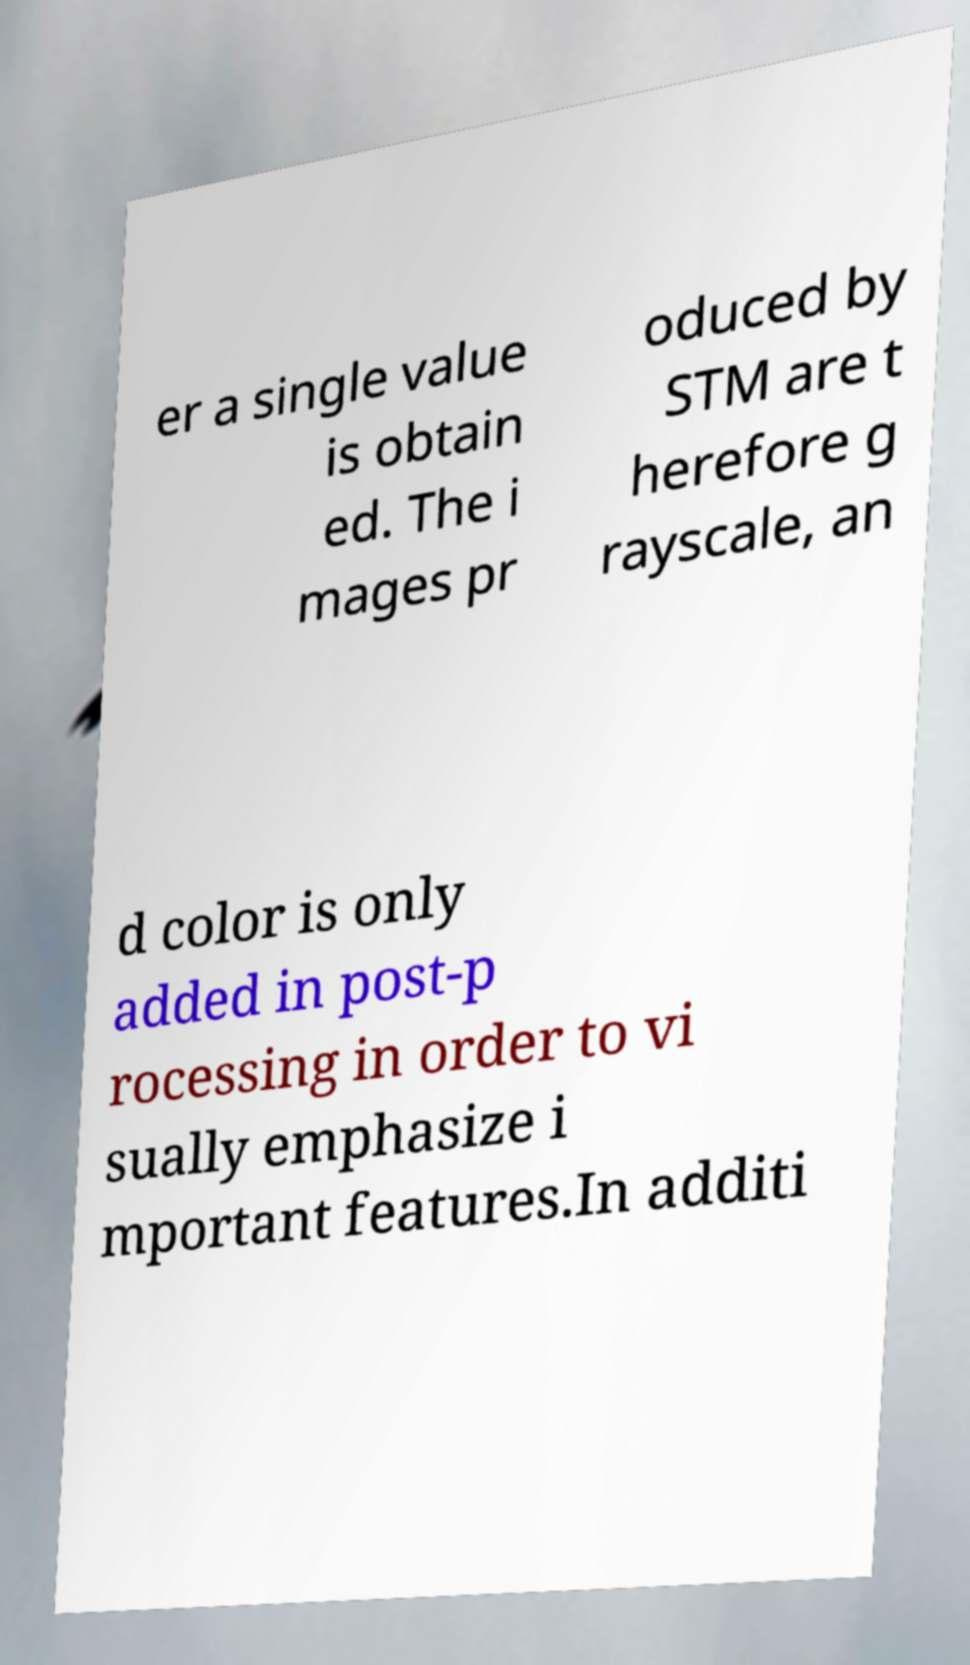Could you extract and type out the text from this image? er a single value is obtain ed. The i mages pr oduced by STM are t herefore g rayscale, an d color is only added in post-p rocessing in order to vi sually emphasize i mportant features.In additi 